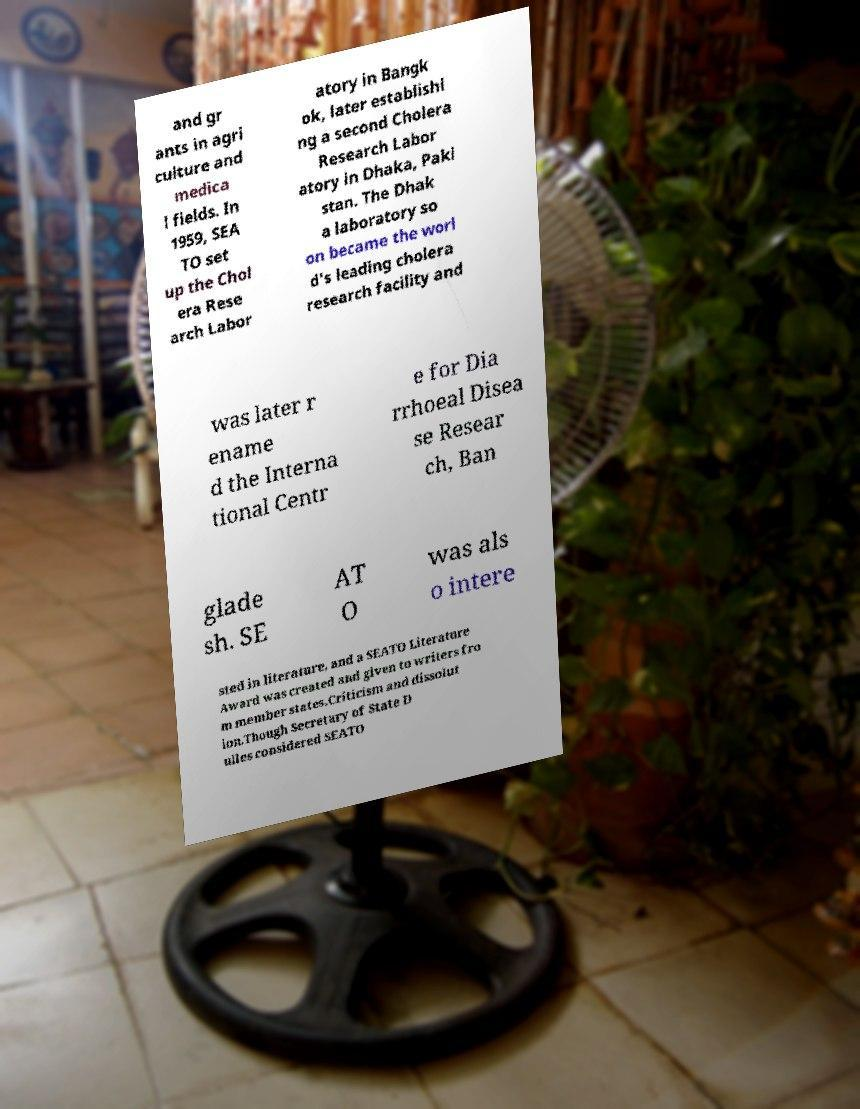Please read and relay the text visible in this image. What does it say? and gr ants in agri culture and medica l fields. In 1959, SEA TO set up the Chol era Rese arch Labor atory in Bangk ok, later establishi ng a second Cholera Research Labor atory in Dhaka, Paki stan. The Dhak a laboratory so on became the worl d's leading cholera research facility and was later r ename d the Interna tional Centr e for Dia rrhoeal Disea se Resear ch, Ban glade sh. SE AT O was als o intere sted in literature, and a SEATO Literature Award was created and given to writers fro m member states.Criticism and dissolut ion.Though Secretary of State D ulles considered SEATO 